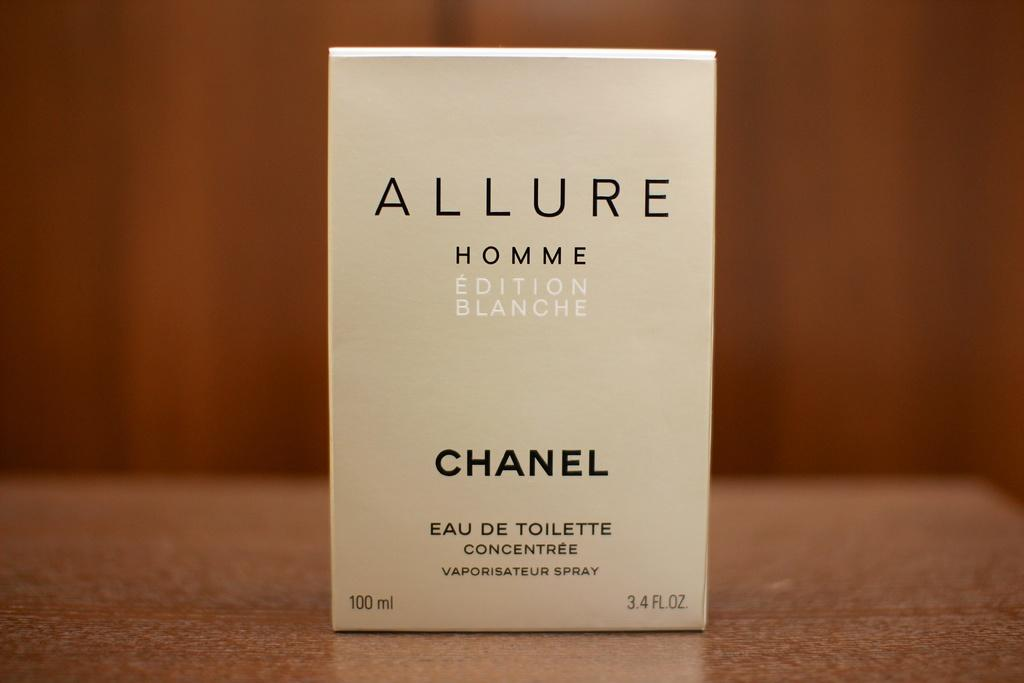Provide a one-sentence caption for the provided image. Allure Homme Eau de Toilette is a product of Chanel. 